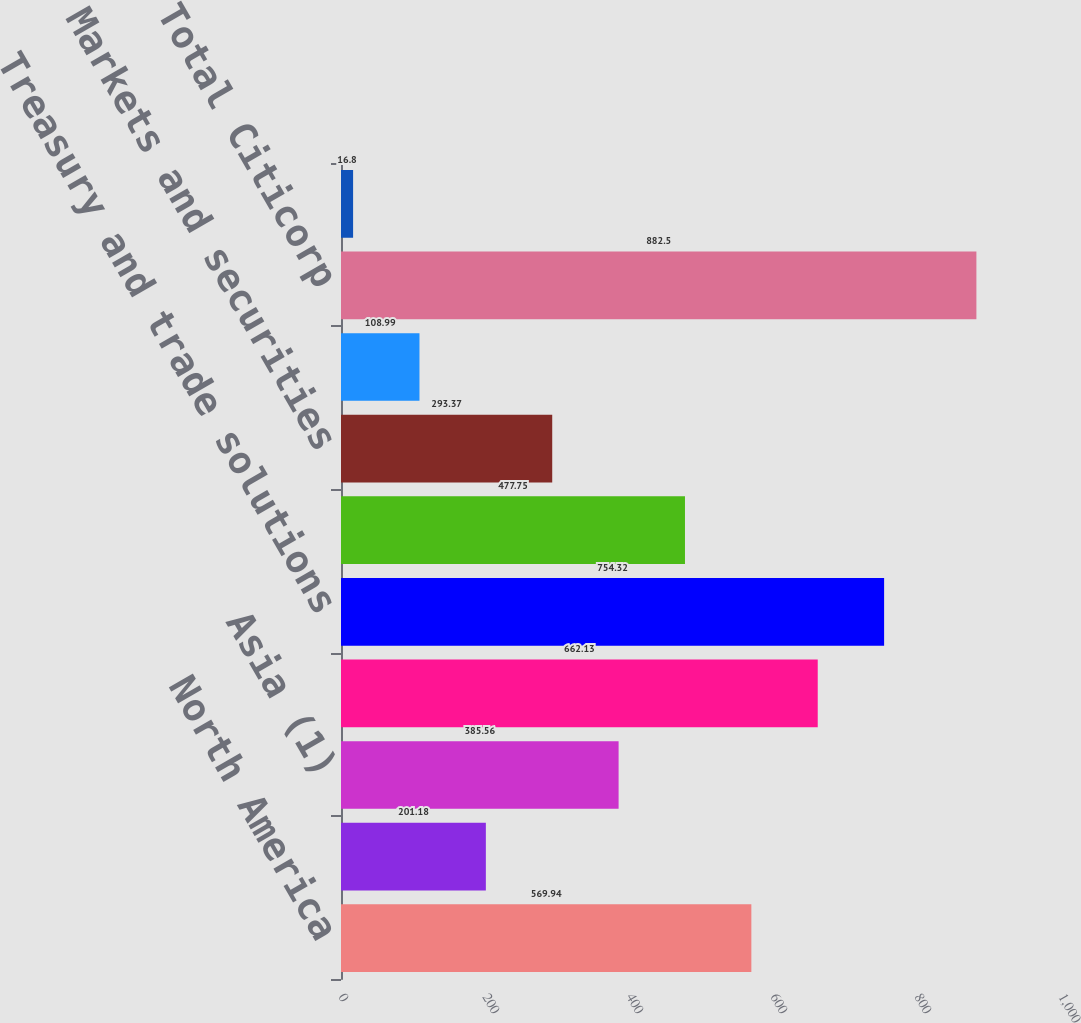Convert chart to OTSL. <chart><loc_0><loc_0><loc_500><loc_500><bar_chart><fcel>North America<fcel>Latin America<fcel>Asia (1)<fcel>Total<fcel>Treasury and trade solutions<fcel>Banking ex-TTS<fcel>Markets and securities<fcel>Corporate/Other<fcel>Total Citicorp<fcel>Total Citi Holdings<nl><fcel>569.94<fcel>201.18<fcel>385.56<fcel>662.13<fcel>754.32<fcel>477.75<fcel>293.37<fcel>108.99<fcel>882.5<fcel>16.8<nl></chart> 